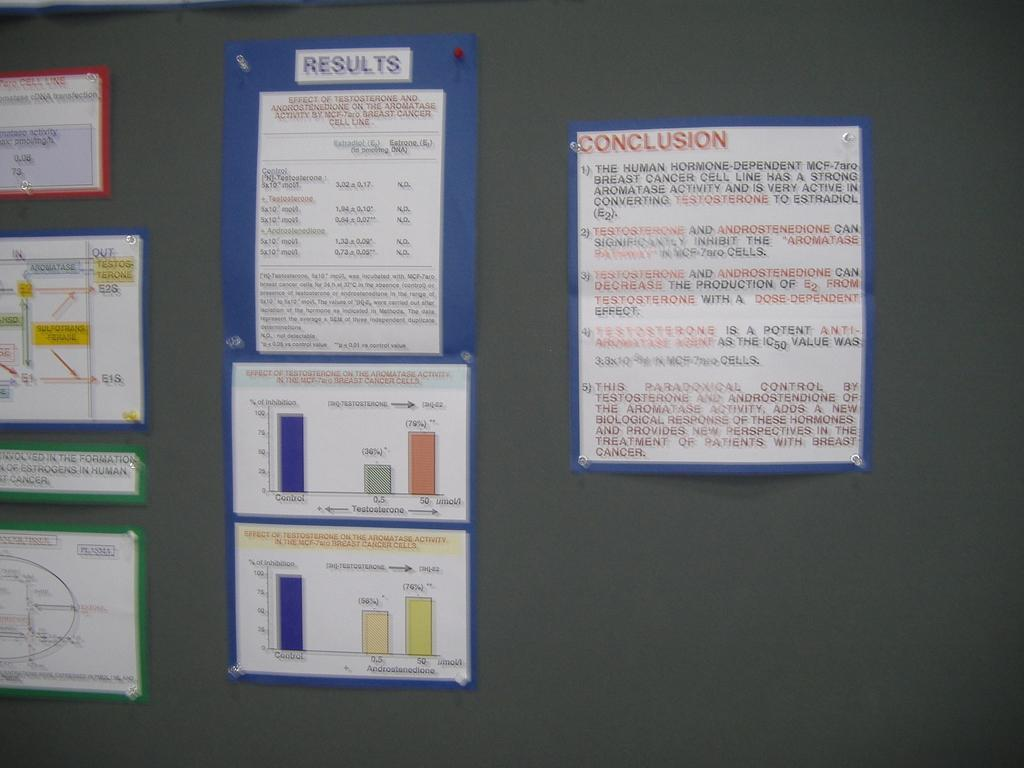<image>
Write a terse but informative summary of the picture. Paper on a gray wall that says "Conclusion" in red. 